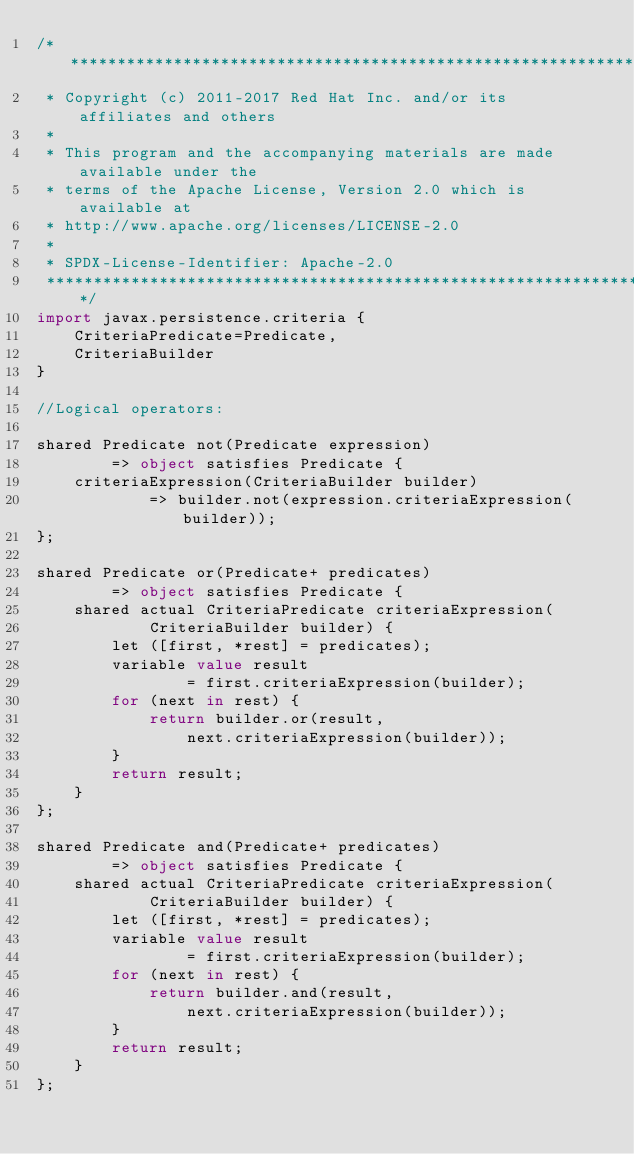Convert code to text. <code><loc_0><loc_0><loc_500><loc_500><_Ceylon_>/********************************************************************************
 * Copyright (c) 2011-2017 Red Hat Inc. and/or its affiliates and others
 *
 * This program and the accompanying materials are made available under the 
 * terms of the Apache License, Version 2.0 which is available at
 * http://www.apache.org/licenses/LICENSE-2.0
 *
 * SPDX-License-Identifier: Apache-2.0 
 ********************************************************************************/
import javax.persistence.criteria {
    CriteriaPredicate=Predicate,
    CriteriaBuilder
}

//Logical operators:

shared Predicate not(Predicate expression)
        => object satisfies Predicate {
    criteriaExpression(CriteriaBuilder builder)
            => builder.not(expression.criteriaExpression(builder));
};

shared Predicate or(Predicate+ predicates)
        => object satisfies Predicate {
    shared actual CriteriaPredicate criteriaExpression(
            CriteriaBuilder builder) {
        let ([first, *rest] = predicates);
        variable value result
                = first.criteriaExpression(builder);
        for (next in rest) {
            return builder.or(result,
                next.criteriaExpression(builder));
        }
        return result;
    }
};

shared Predicate and(Predicate+ predicates)
        => object satisfies Predicate {
    shared actual CriteriaPredicate criteriaExpression(
            CriteriaBuilder builder) {
        let ([first, *rest] = predicates);
        variable value result
                = first.criteriaExpression(builder);
        for (next in rest) {
            return builder.and(result,
                next.criteriaExpression(builder));
        }
        return result;
    }
};

</code> 